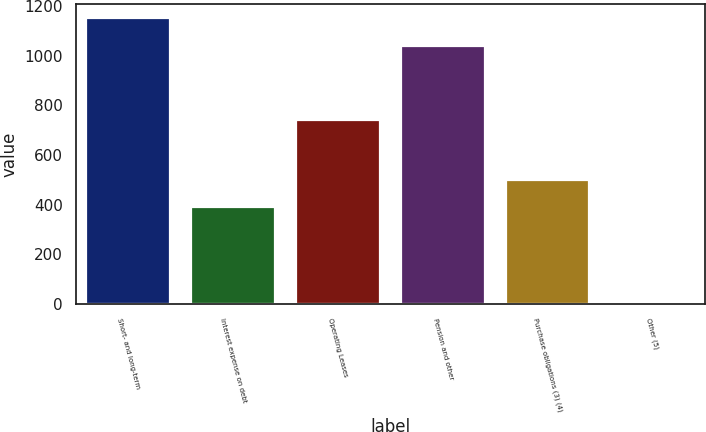<chart> <loc_0><loc_0><loc_500><loc_500><bar_chart><fcel>Short- and long-term<fcel>Interest expense on debt<fcel>Operating Leases<fcel>Pension and other<fcel>Purchase obligations (3) (4)<fcel>Other (5)<nl><fcel>1150.8<fcel>391<fcel>740<fcel>1040<fcel>501.8<fcel>1<nl></chart> 